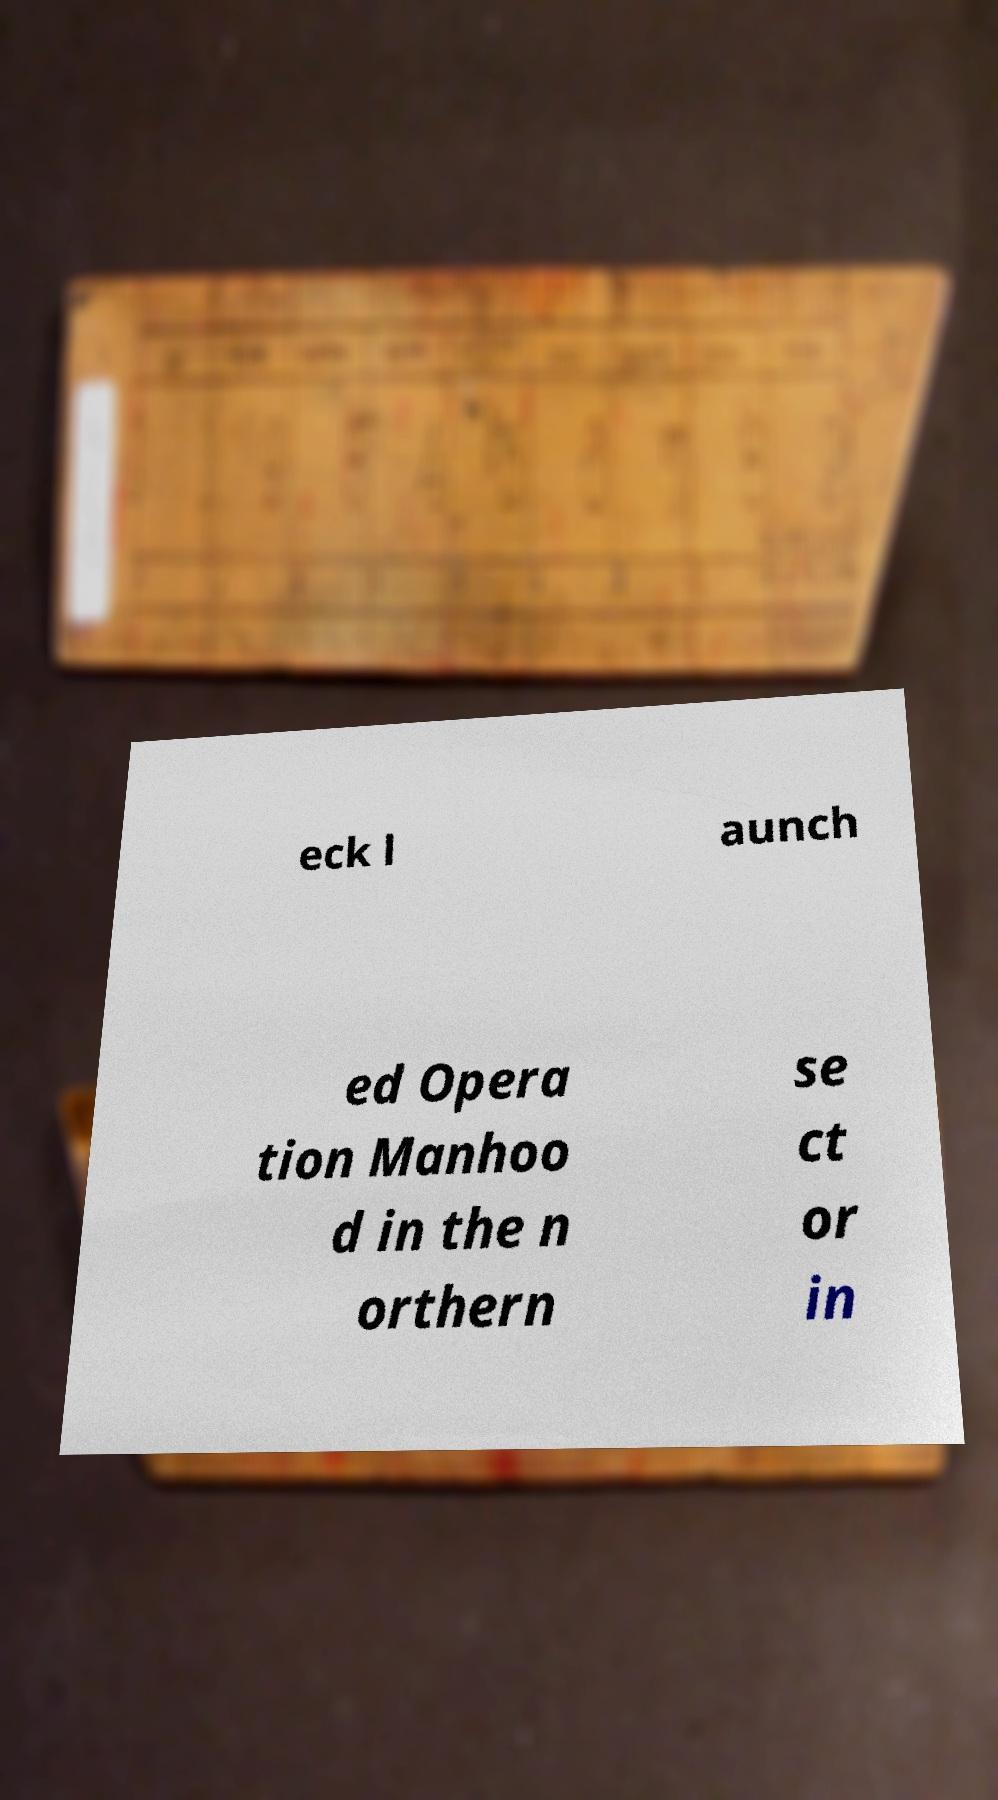Please identify and transcribe the text found in this image. eck l aunch ed Opera tion Manhoo d in the n orthern se ct or in 